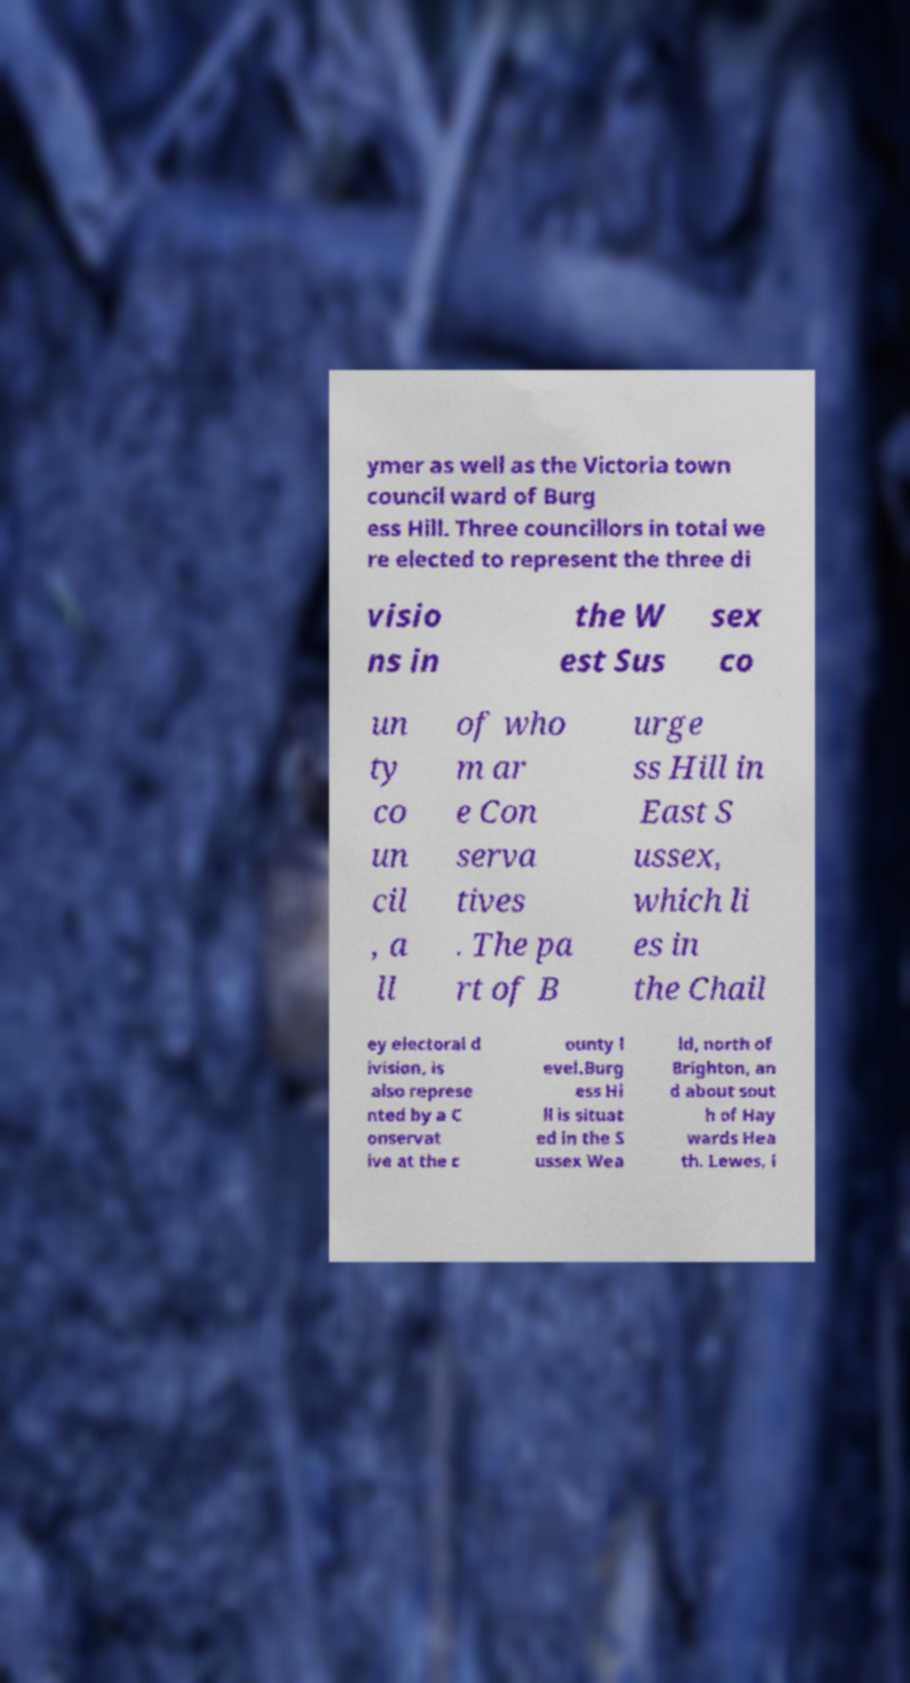Could you extract and type out the text from this image? ymer as well as the Victoria town council ward of Burg ess Hill. Three councillors in total we re elected to represent the three di visio ns in the W est Sus sex co un ty co un cil , a ll of who m ar e Con serva tives . The pa rt of B urge ss Hill in East S ussex, which li es in the Chail ey electoral d ivision, is also represe nted by a C onservat ive at the c ounty l evel.Burg ess Hi ll is situat ed in the S ussex Wea ld, north of Brighton, an d about sout h of Hay wards Hea th. Lewes, i 